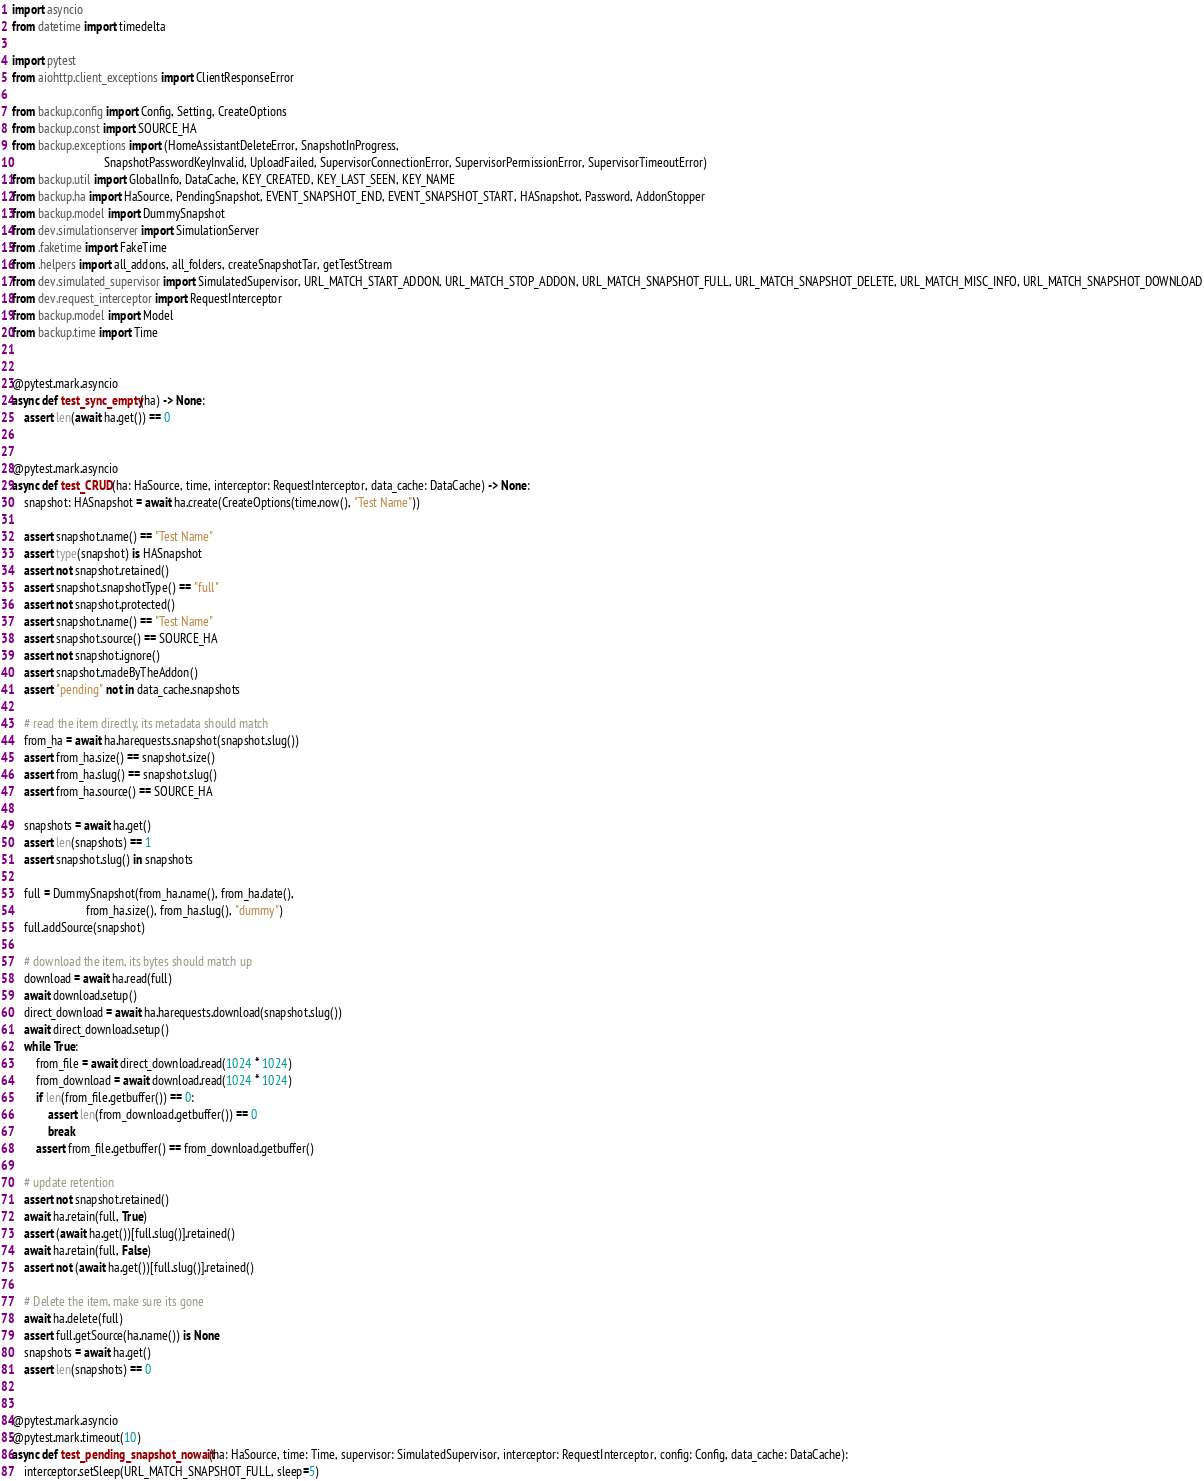<code> <loc_0><loc_0><loc_500><loc_500><_Python_>import asyncio
from datetime import timedelta

import pytest
from aiohttp.client_exceptions import ClientResponseError

from backup.config import Config, Setting, CreateOptions
from backup.const import SOURCE_HA
from backup.exceptions import (HomeAssistantDeleteError, SnapshotInProgress,
                               SnapshotPasswordKeyInvalid, UploadFailed, SupervisorConnectionError, SupervisorPermissionError, SupervisorTimeoutError)
from backup.util import GlobalInfo, DataCache, KEY_CREATED, KEY_LAST_SEEN, KEY_NAME
from backup.ha import HaSource, PendingSnapshot, EVENT_SNAPSHOT_END, EVENT_SNAPSHOT_START, HASnapshot, Password, AddonStopper
from backup.model import DummySnapshot
from dev.simulationserver import SimulationServer
from .faketime import FakeTime
from .helpers import all_addons, all_folders, createSnapshotTar, getTestStream
from dev.simulated_supervisor import SimulatedSupervisor, URL_MATCH_START_ADDON, URL_MATCH_STOP_ADDON, URL_MATCH_SNAPSHOT_FULL, URL_MATCH_SNAPSHOT_DELETE, URL_MATCH_MISC_INFO, URL_MATCH_SNAPSHOT_DOWNLOAD
from dev.request_interceptor import RequestInterceptor
from backup.model import Model
from backup.time import Time


@pytest.mark.asyncio
async def test_sync_empty(ha) -> None:
    assert len(await ha.get()) == 0


@pytest.mark.asyncio
async def test_CRUD(ha: HaSource, time, interceptor: RequestInterceptor, data_cache: DataCache) -> None:
    snapshot: HASnapshot = await ha.create(CreateOptions(time.now(), "Test Name"))

    assert snapshot.name() == "Test Name"
    assert type(snapshot) is HASnapshot
    assert not snapshot.retained()
    assert snapshot.snapshotType() == "full"
    assert not snapshot.protected()
    assert snapshot.name() == "Test Name"
    assert snapshot.source() == SOURCE_HA
    assert not snapshot.ignore()
    assert snapshot.madeByTheAddon()
    assert "pending" not in data_cache.snapshots

    # read the item directly, its metadata should match
    from_ha = await ha.harequests.snapshot(snapshot.slug())
    assert from_ha.size() == snapshot.size()
    assert from_ha.slug() == snapshot.slug()
    assert from_ha.source() == SOURCE_HA

    snapshots = await ha.get()
    assert len(snapshots) == 1
    assert snapshot.slug() in snapshots

    full = DummySnapshot(from_ha.name(), from_ha.date(),
                         from_ha.size(), from_ha.slug(), "dummy")
    full.addSource(snapshot)

    # download the item, its bytes should match up
    download = await ha.read(full)
    await download.setup()
    direct_download = await ha.harequests.download(snapshot.slug())
    await direct_download.setup()
    while True:
        from_file = await direct_download.read(1024 * 1024)
        from_download = await download.read(1024 * 1024)
        if len(from_file.getbuffer()) == 0:
            assert len(from_download.getbuffer()) == 0
            break
        assert from_file.getbuffer() == from_download.getbuffer()

    # update retention
    assert not snapshot.retained()
    await ha.retain(full, True)
    assert (await ha.get())[full.slug()].retained()
    await ha.retain(full, False)
    assert not (await ha.get())[full.slug()].retained()

    # Delete the item, make sure its gone
    await ha.delete(full)
    assert full.getSource(ha.name()) is None
    snapshots = await ha.get()
    assert len(snapshots) == 0


@pytest.mark.asyncio
@pytest.mark.timeout(10)
async def test_pending_snapshot_nowait(ha: HaSource, time: Time, supervisor: SimulatedSupervisor, interceptor: RequestInterceptor, config: Config, data_cache: DataCache):
    interceptor.setSleep(URL_MATCH_SNAPSHOT_FULL, sleep=5)</code> 